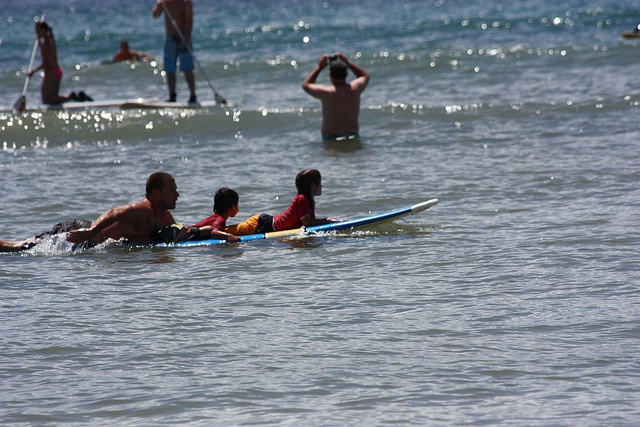Describe the objects in this image and their specific colors. I can see people in gray, black, maroon, and brown tones, people in gray, black, and maroon tones, people in gray, black, maroon, and darkgray tones, surfboard in gray, black, lightgray, and darkgray tones, and people in gray, black, navy, and blue tones in this image. 